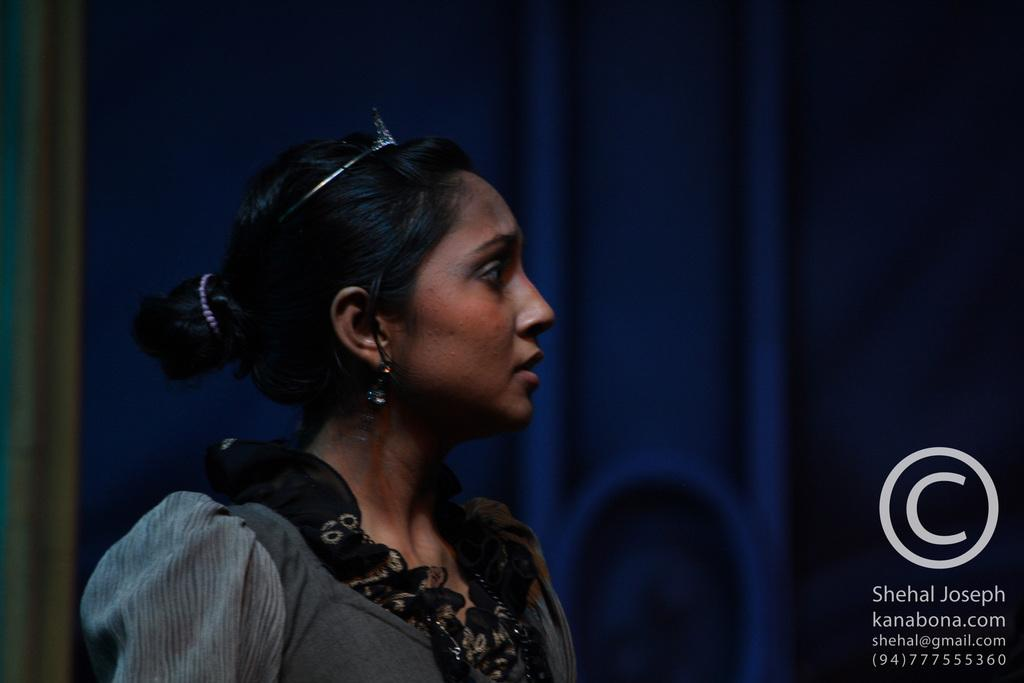Who is present in the image? There is a woman in the image. What is the woman wearing? The woman is wearing a dress with black, white, and grey colors. Can you describe any additional features of the image? There is a watermark in the image. What can be seen in the background of the image? There is a blue color thing in the background of the image. What type of exchange is taking place between the woman and the heart in the image? There is no heart present in the image, and therefore no exchange can be observed. What is the woman using the hammer for in the image? There is no hammer present in the image, so it cannot be determined what the woman might be using it for. 